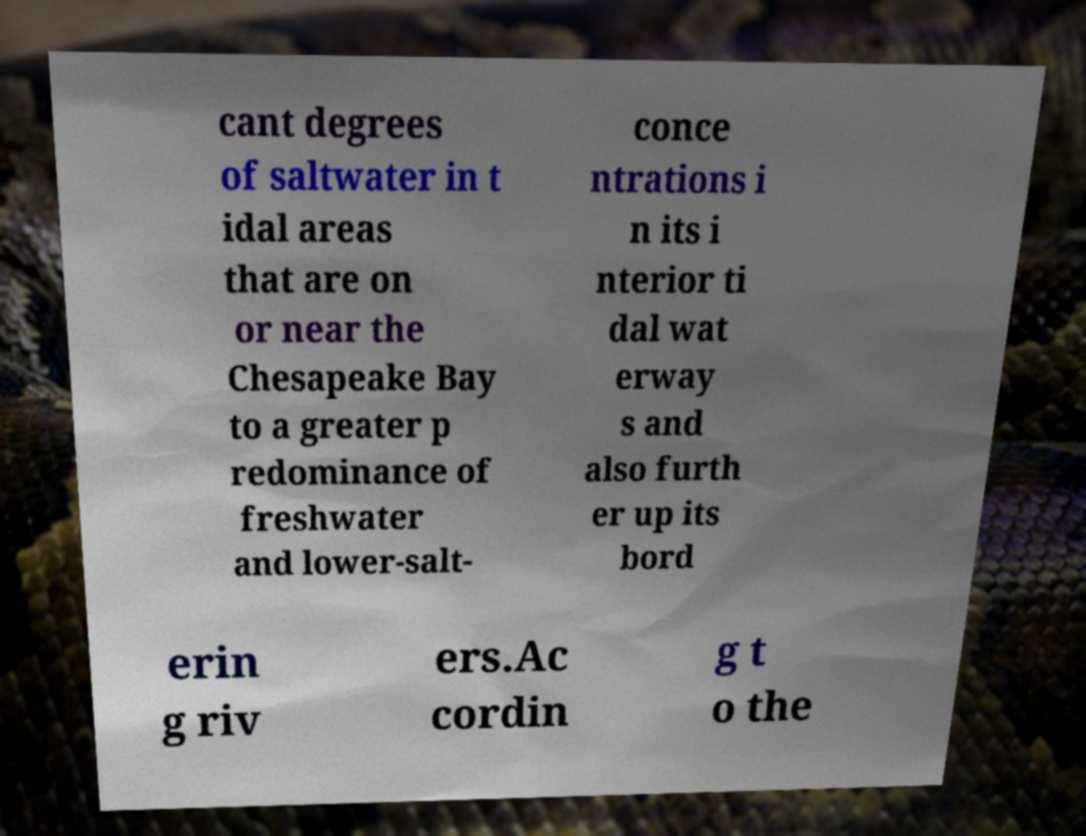Please identify and transcribe the text found in this image. cant degrees of saltwater in t idal areas that are on or near the Chesapeake Bay to a greater p redominance of freshwater and lower-salt- conce ntrations i n its i nterior ti dal wat erway s and also furth er up its bord erin g riv ers.Ac cordin g t o the 